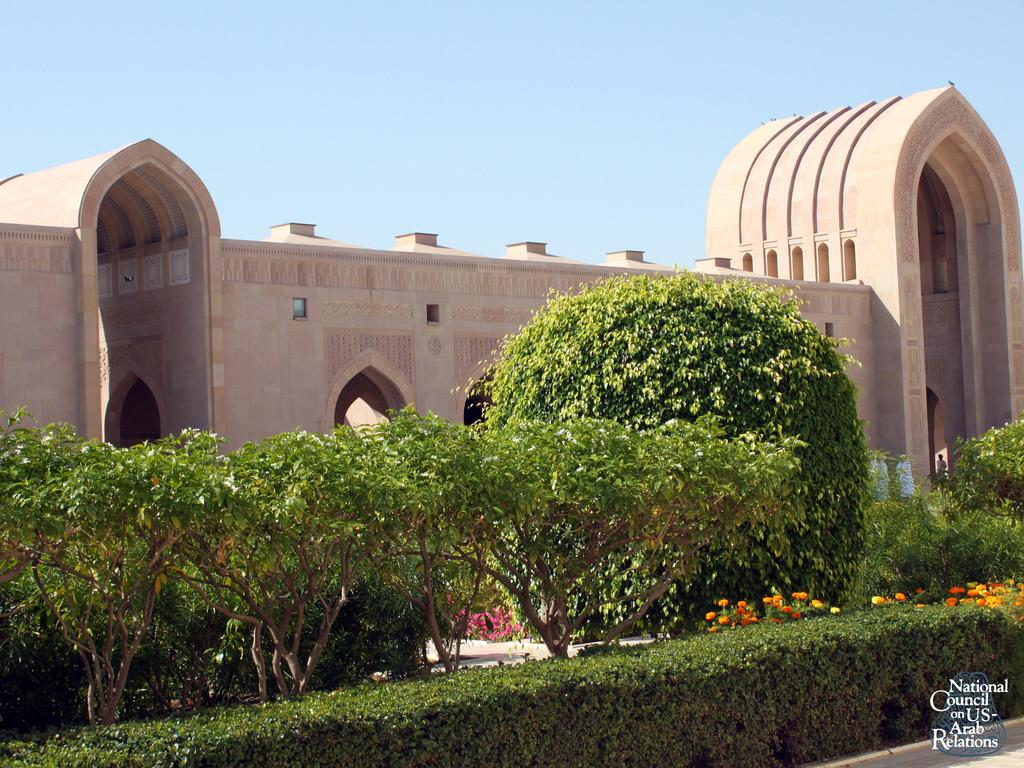What can be seen in the sky in the image? There is sky visible in the image. What type of structure is present in the image? There is a building in the image. What type of vegetation is present in the image? Bushes, shrubs, plants, and trees are present in the image. What type of curtain can be seen hanging from the trees in the image? There is no curtain present in the image; it features a sky, a building, and various types of vegetation. Where are the toys located in the image? There are no toys present in the image. 